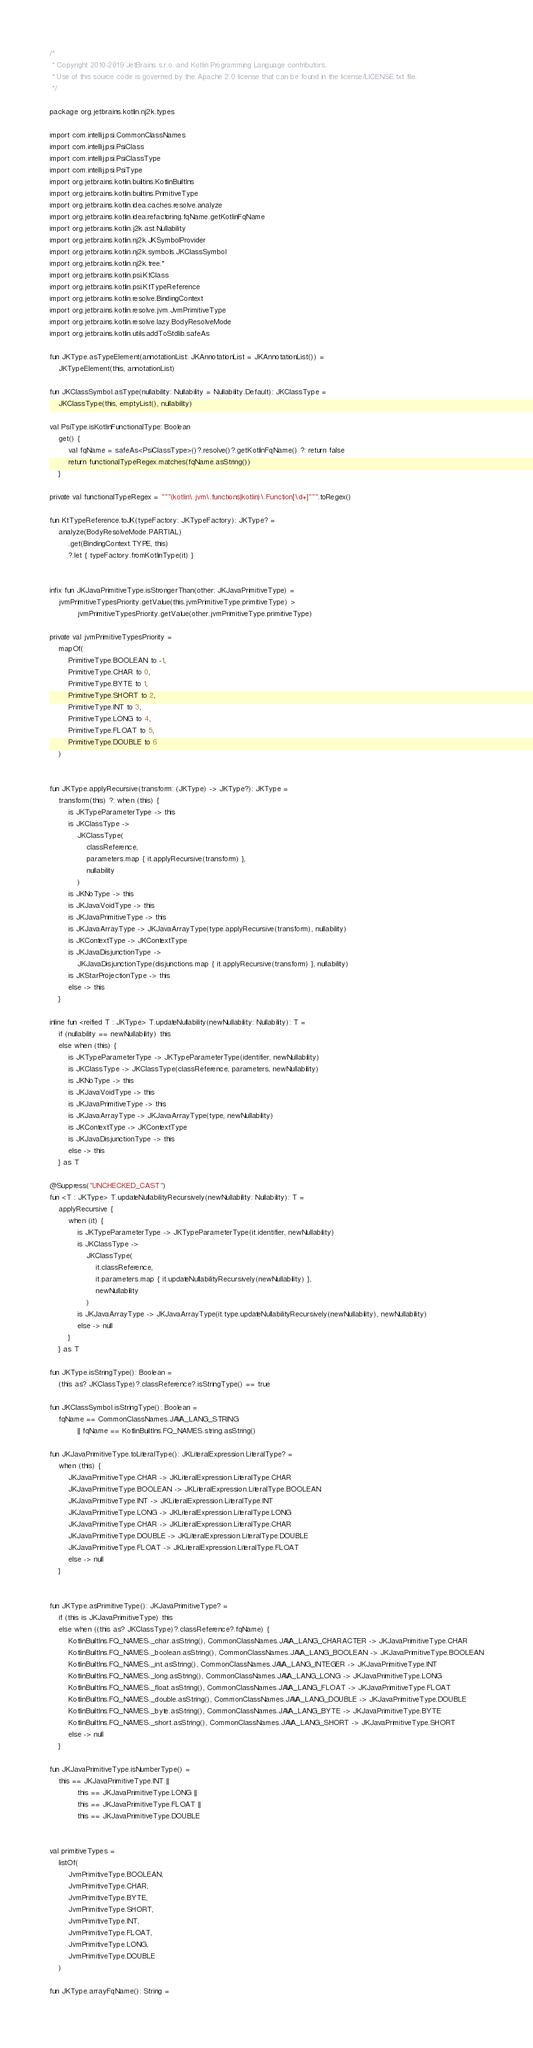<code> <loc_0><loc_0><loc_500><loc_500><_Kotlin_>/*
 * Copyright 2010-2019 JetBrains s.r.o. and Kotlin Programming Language contributors.
 * Use of this source code is governed by the Apache 2.0 license that can be found in the license/LICENSE.txt file.
 */

package org.jetbrains.kotlin.nj2k.types

import com.intellij.psi.CommonClassNames
import com.intellij.psi.PsiClass
import com.intellij.psi.PsiClassType
import com.intellij.psi.PsiType
import org.jetbrains.kotlin.builtins.KotlinBuiltIns
import org.jetbrains.kotlin.builtins.PrimitiveType
import org.jetbrains.kotlin.idea.caches.resolve.analyze
import org.jetbrains.kotlin.idea.refactoring.fqName.getKotlinFqName
import org.jetbrains.kotlin.j2k.ast.Nullability
import org.jetbrains.kotlin.nj2k.JKSymbolProvider
import org.jetbrains.kotlin.nj2k.symbols.JKClassSymbol
import org.jetbrains.kotlin.nj2k.tree.*
import org.jetbrains.kotlin.psi.KtClass
import org.jetbrains.kotlin.psi.KtTypeReference
import org.jetbrains.kotlin.resolve.BindingContext
import org.jetbrains.kotlin.resolve.jvm.JvmPrimitiveType
import org.jetbrains.kotlin.resolve.lazy.BodyResolveMode
import org.jetbrains.kotlin.utils.addToStdlib.safeAs

fun JKType.asTypeElement(annotationList: JKAnnotationList = JKAnnotationList()) =
    JKTypeElement(this, annotationList)

fun JKClassSymbol.asType(nullability: Nullability = Nullability.Default): JKClassType =
    JKClassType(this, emptyList(), nullability)

val PsiType.isKotlinFunctionalType: Boolean
    get() {
        val fqName = safeAs<PsiClassType>()?.resolve()?.getKotlinFqName() ?: return false
        return functionalTypeRegex.matches(fqName.asString())
    }

private val functionalTypeRegex = """(kotlin\.jvm\.functions|kotlin)\.Function[\d+]""".toRegex()

fun KtTypeReference.toJK(typeFactory: JKTypeFactory): JKType? =
    analyze(BodyResolveMode.PARTIAL)
        .get(BindingContext.TYPE, this)
        ?.let { typeFactory.fromKotlinType(it) }


infix fun JKJavaPrimitiveType.isStrongerThan(other: JKJavaPrimitiveType) =
    jvmPrimitiveTypesPriority.getValue(this.jvmPrimitiveType.primitiveType) >
            jvmPrimitiveTypesPriority.getValue(other.jvmPrimitiveType.primitiveType)

private val jvmPrimitiveTypesPriority =
    mapOf(
        PrimitiveType.BOOLEAN to -1,
        PrimitiveType.CHAR to 0,
        PrimitiveType.BYTE to 1,
        PrimitiveType.SHORT to 2,
        PrimitiveType.INT to 3,
        PrimitiveType.LONG to 4,
        PrimitiveType.FLOAT to 5,
        PrimitiveType.DOUBLE to 6
    )


fun JKType.applyRecursive(transform: (JKType) -> JKType?): JKType =
    transform(this) ?: when (this) {
        is JKTypeParameterType -> this
        is JKClassType ->
            JKClassType(
                classReference,
                parameters.map { it.applyRecursive(transform) },
                nullability
            )
        is JKNoType -> this
        is JKJavaVoidType -> this
        is JKJavaPrimitiveType -> this
        is JKJavaArrayType -> JKJavaArrayType(type.applyRecursive(transform), nullability)
        is JKContextType -> JKContextType
        is JKJavaDisjunctionType ->
            JKJavaDisjunctionType(disjunctions.map { it.applyRecursive(transform) }, nullability)
        is JKStarProjectionType -> this
        else -> this
    }

inline fun <reified T : JKType> T.updateNullability(newNullability: Nullability): T =
    if (nullability == newNullability) this
    else when (this) {
        is JKTypeParameterType -> JKTypeParameterType(identifier, newNullability)
        is JKClassType -> JKClassType(classReference, parameters, newNullability)
        is JKNoType -> this
        is JKJavaVoidType -> this
        is JKJavaPrimitiveType -> this
        is JKJavaArrayType -> JKJavaArrayType(type, newNullability)
        is JKContextType -> JKContextType
        is JKJavaDisjunctionType -> this
        else -> this
    } as T

@Suppress("UNCHECKED_CAST")
fun <T : JKType> T.updateNullabilityRecursively(newNullability: Nullability): T =
    applyRecursive {
        when (it) {
            is JKTypeParameterType -> JKTypeParameterType(it.identifier, newNullability)
            is JKClassType ->
                JKClassType(
                    it.classReference,
                    it.parameters.map { it.updateNullabilityRecursively(newNullability) },
                    newNullability
                )
            is JKJavaArrayType -> JKJavaArrayType(it.type.updateNullabilityRecursively(newNullability), newNullability)
            else -> null
        }
    } as T

fun JKType.isStringType(): Boolean =
    (this as? JKClassType)?.classReference?.isStringType() == true

fun JKClassSymbol.isStringType(): Boolean =
    fqName == CommonClassNames.JAVA_LANG_STRING
            || fqName == KotlinBuiltIns.FQ_NAMES.string.asString()

fun JKJavaPrimitiveType.toLiteralType(): JKLiteralExpression.LiteralType? =
    when (this) {
        JKJavaPrimitiveType.CHAR -> JKLiteralExpression.LiteralType.CHAR
        JKJavaPrimitiveType.BOOLEAN -> JKLiteralExpression.LiteralType.BOOLEAN
        JKJavaPrimitiveType.INT -> JKLiteralExpression.LiteralType.INT
        JKJavaPrimitiveType.LONG -> JKLiteralExpression.LiteralType.LONG
        JKJavaPrimitiveType.CHAR -> JKLiteralExpression.LiteralType.CHAR
        JKJavaPrimitiveType.DOUBLE -> JKLiteralExpression.LiteralType.DOUBLE
        JKJavaPrimitiveType.FLOAT -> JKLiteralExpression.LiteralType.FLOAT
        else -> null
    }


fun JKType.asPrimitiveType(): JKJavaPrimitiveType? =
    if (this is JKJavaPrimitiveType) this
    else when ((this as? JKClassType)?.classReference?.fqName) {
        KotlinBuiltIns.FQ_NAMES._char.asString(), CommonClassNames.JAVA_LANG_CHARACTER -> JKJavaPrimitiveType.CHAR
        KotlinBuiltIns.FQ_NAMES._boolean.asString(), CommonClassNames.JAVA_LANG_BOOLEAN -> JKJavaPrimitiveType.BOOLEAN
        KotlinBuiltIns.FQ_NAMES._int.asString(), CommonClassNames.JAVA_LANG_INTEGER -> JKJavaPrimitiveType.INT
        KotlinBuiltIns.FQ_NAMES._long.asString(), CommonClassNames.JAVA_LANG_LONG -> JKJavaPrimitiveType.LONG
        KotlinBuiltIns.FQ_NAMES._float.asString(), CommonClassNames.JAVA_LANG_FLOAT -> JKJavaPrimitiveType.FLOAT
        KotlinBuiltIns.FQ_NAMES._double.asString(), CommonClassNames.JAVA_LANG_DOUBLE -> JKJavaPrimitiveType.DOUBLE
        KotlinBuiltIns.FQ_NAMES._byte.asString(), CommonClassNames.JAVA_LANG_BYTE -> JKJavaPrimitiveType.BYTE
        KotlinBuiltIns.FQ_NAMES._short.asString(), CommonClassNames.JAVA_LANG_SHORT -> JKJavaPrimitiveType.SHORT
        else -> null
    }

fun JKJavaPrimitiveType.isNumberType() =
    this == JKJavaPrimitiveType.INT ||
            this == JKJavaPrimitiveType.LONG ||
            this == JKJavaPrimitiveType.FLOAT ||
            this == JKJavaPrimitiveType.DOUBLE


val primitiveTypes =
    listOf(
        JvmPrimitiveType.BOOLEAN,
        JvmPrimitiveType.CHAR,
        JvmPrimitiveType.BYTE,
        JvmPrimitiveType.SHORT,
        JvmPrimitiveType.INT,
        JvmPrimitiveType.FLOAT,
        JvmPrimitiveType.LONG,
        JvmPrimitiveType.DOUBLE
    )

fun JKType.arrayFqName(): String =</code> 